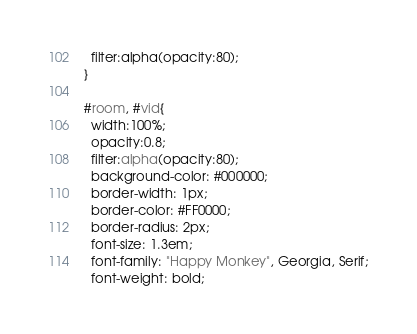Convert code to text. <code><loc_0><loc_0><loc_500><loc_500><_CSS_>  filter:alpha(opacity:80);
}

#room, #vid{
  width:100%;
  opacity:0.8;
  filter:alpha(opacity:80);
  background-color: #000000;
  border-width: 1px;
  border-color: #FF0000;
  border-radius: 2px;
  font-size: 1.3em;
  font-family: "Happy Monkey", Georgia, Serif;
  font-weight: bold;</code> 